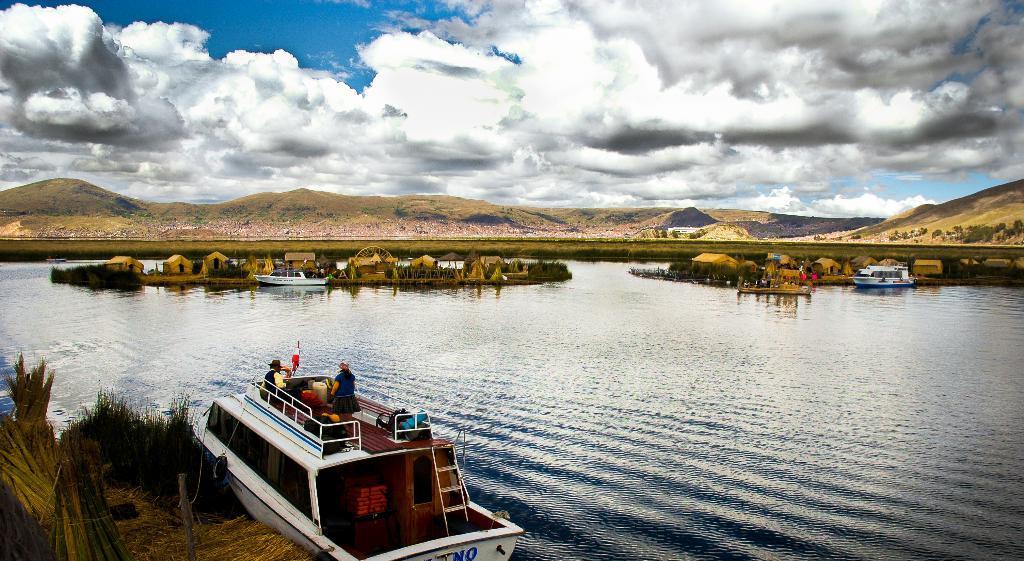Describe this image in one or two sentences. In this image we can see some persons on boat placed in the water. In the foreground, we can see some grass. In the background, we can see a group of huts and boats, mountains and the cloudy sky. 